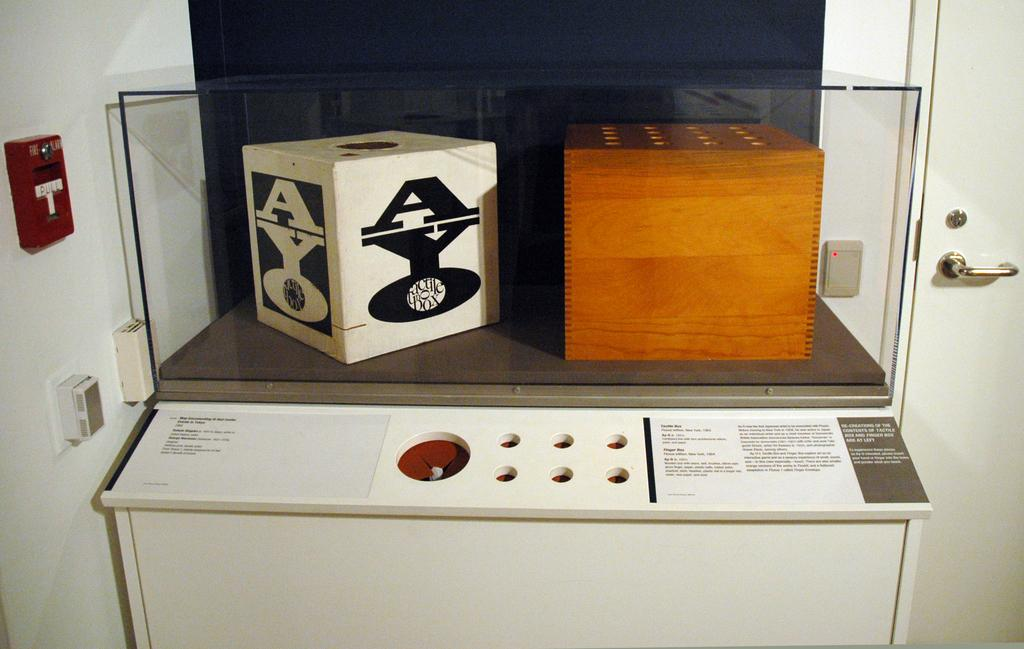Provide a one-sentence caption for the provided image. A white display case has a white box labeled "AYO" vertically on the left of another wooden box. 